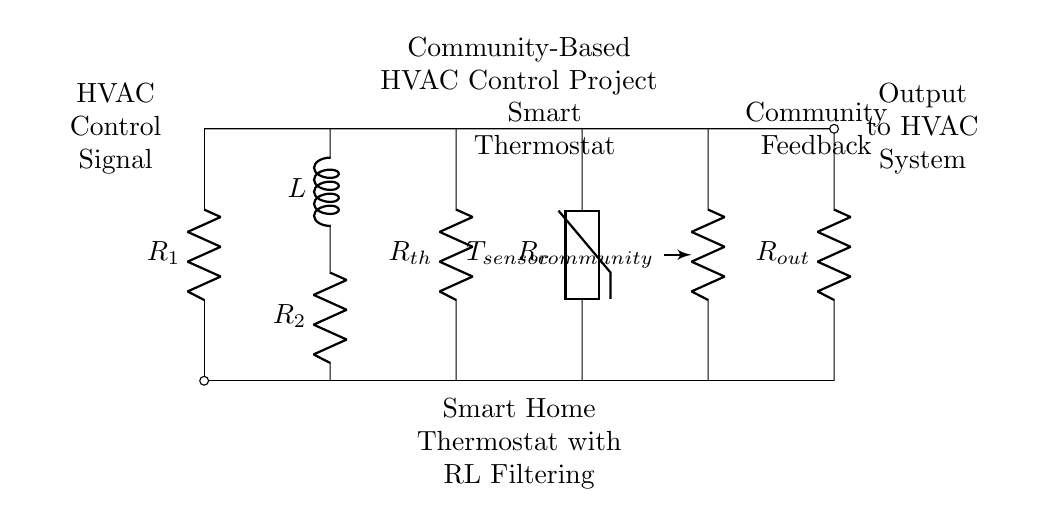What is the purpose of R1? R1 is connected to the HVAC control signal, indicating that it is likely used to regulate or provide a control voltage for the HVAC system.
Answer: HVAC Control Signal What does the inductor represent in the circuit? The inductor, labeled L, is part of an RL filter configuration and is used to smooth out the control signal by filtering out high-frequency noise.
Answer: Inductor How many resistors are present in the circuit? There are four resistors present: R1, R2, Rth, and Rout.
Answer: Four What type of sensor is used in this circuit? The circuit includes a thermistor, which measures temperature and provides feedback to the thermostat.
Answer: Thermistor How are community inputs factored into the HVAC control? The community feedback section indicates that inputs from residents (through Rcommunity) inform the HVAC control output, improving collective temperature management.
Answer: Community Feedback Why is an RL filter used in the smart thermostat? The RL filter helps in reducing noise and stabilizing the control signal to ensure smooth operations of the HVAC, allowing for more efficient temperature control.
Answer: Noise reduction 